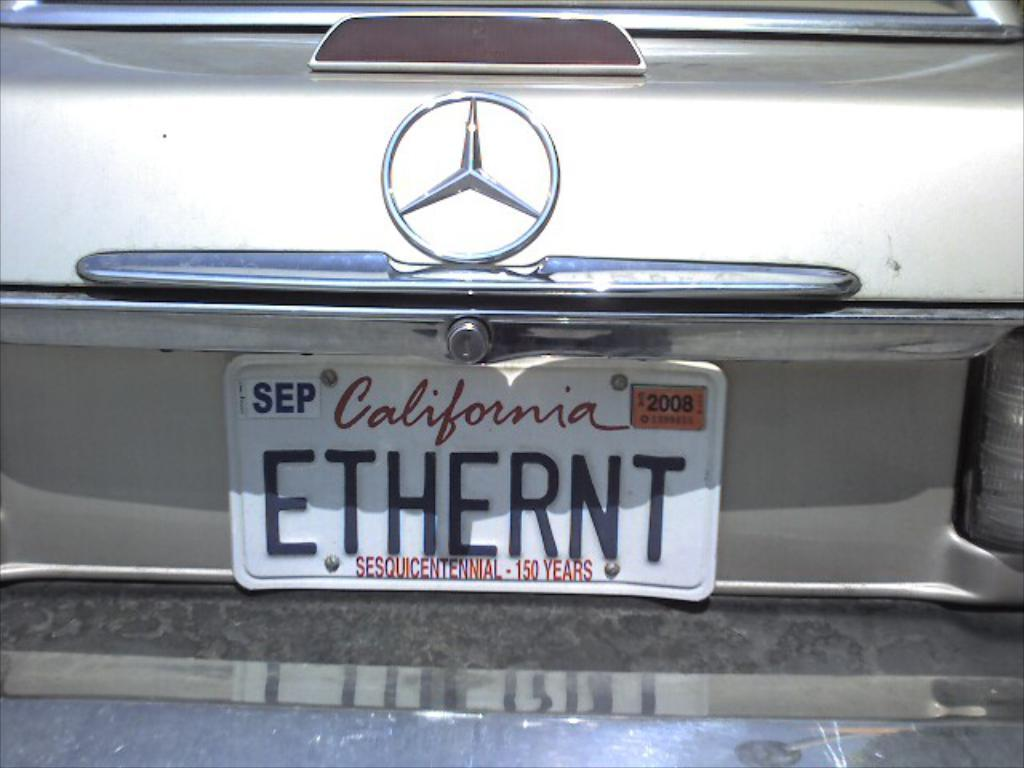<image>
Present a compact description of the photo's key features. A Mercedes has a California license plate with a yellow 2008 sticker in the corner. 